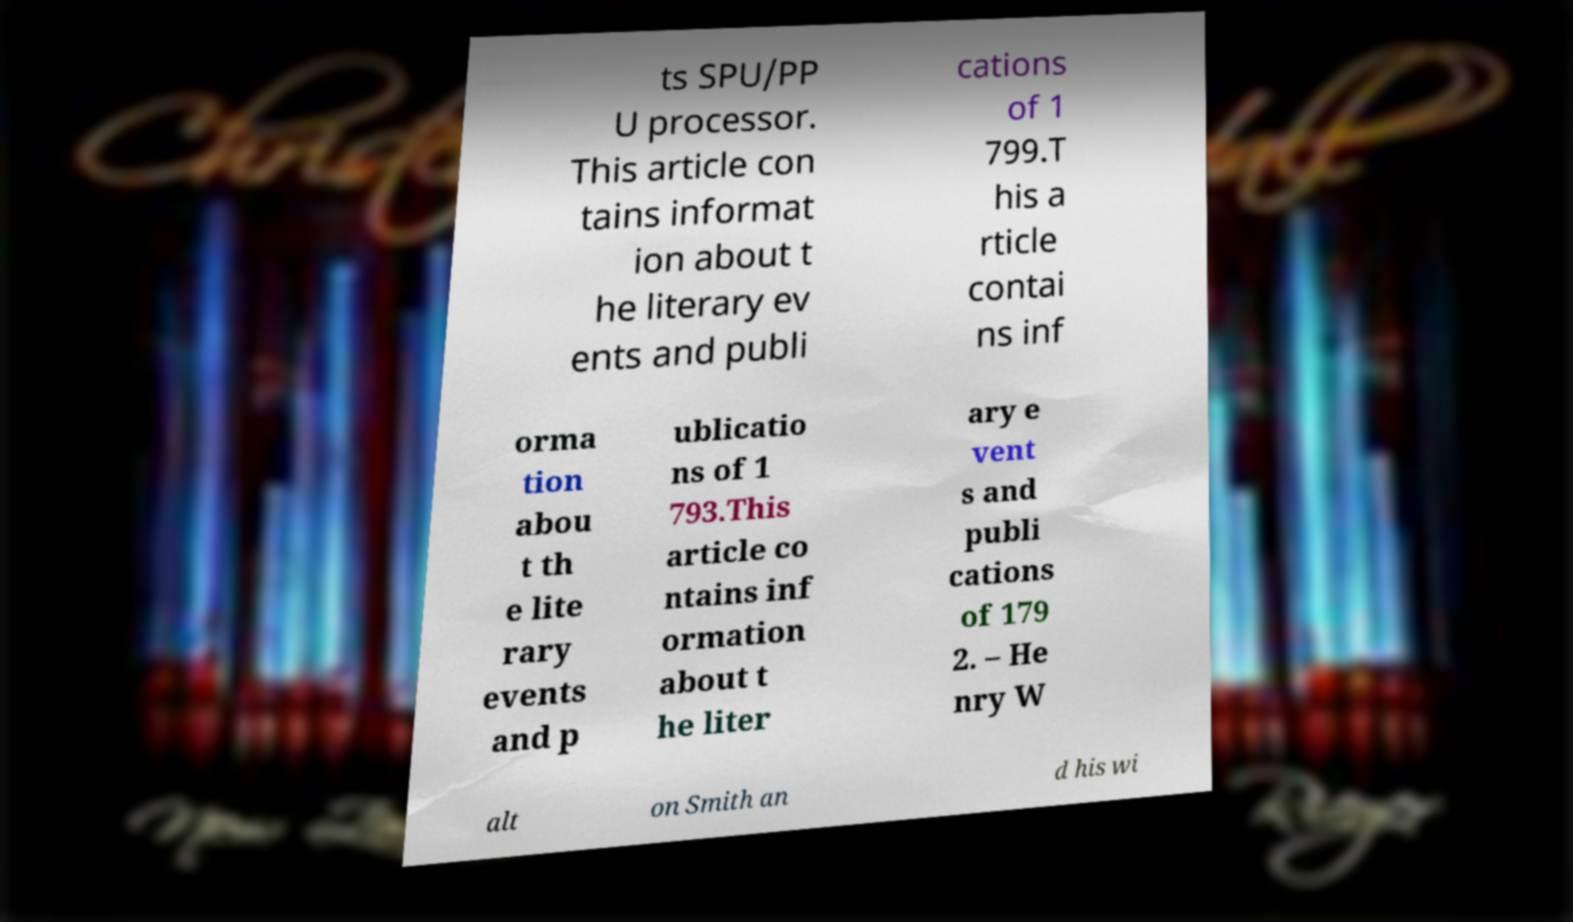Could you assist in decoding the text presented in this image and type it out clearly? ts SPU/PP U processor. This article con tains informat ion about t he literary ev ents and publi cations of 1 799.T his a rticle contai ns inf orma tion abou t th e lite rary events and p ublicatio ns of 1 793.This article co ntains inf ormation about t he liter ary e vent s and publi cations of 179 2. – He nry W alt on Smith an d his wi 